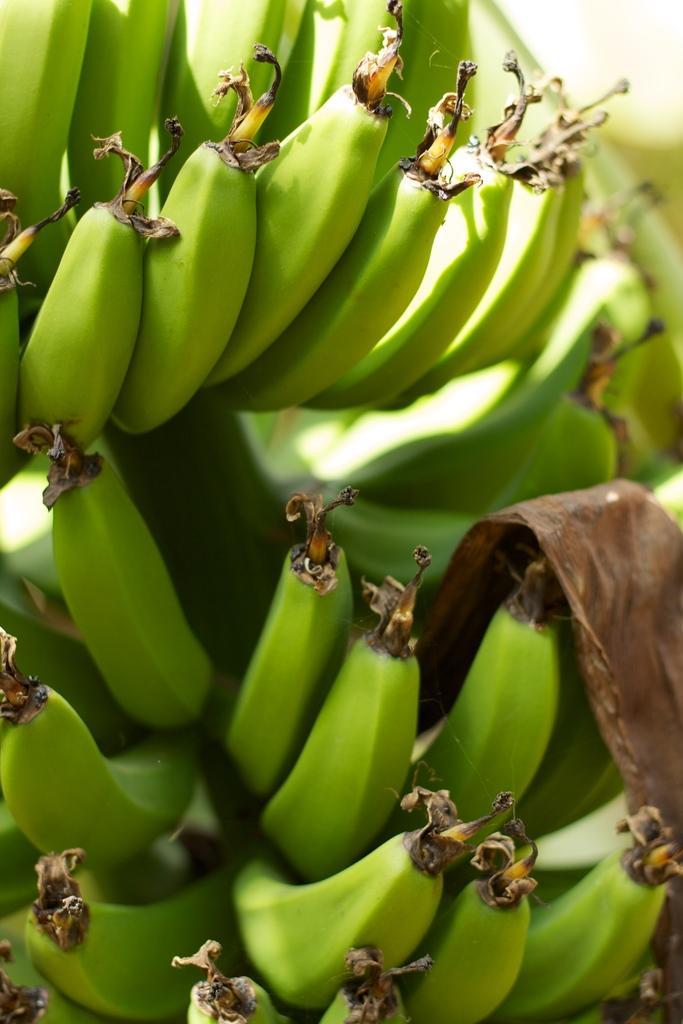How would you summarize this image in a sentence or two? In this picture I can see few unripe bananas. 